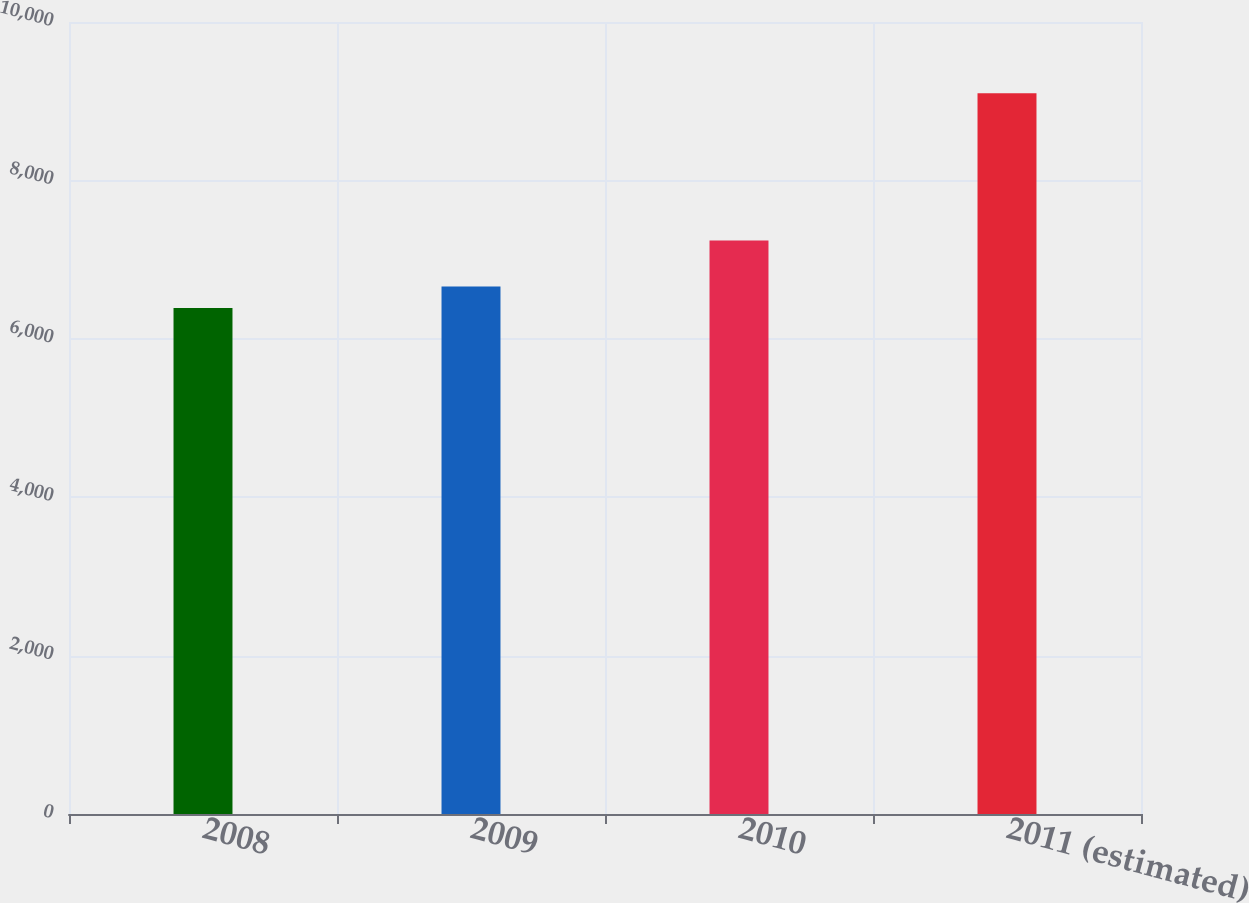<chart> <loc_0><loc_0><loc_500><loc_500><bar_chart><fcel>2008<fcel>2009<fcel>2010<fcel>2011 (estimated)<nl><fcel>6389<fcel>6660.1<fcel>7242<fcel>9100<nl></chart> 